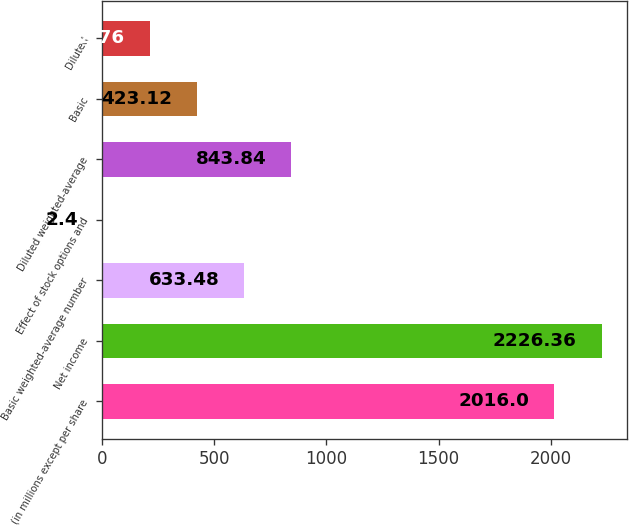<chart> <loc_0><loc_0><loc_500><loc_500><bar_chart><fcel>(in millions except per share<fcel>Net income<fcel>Basic weighted-average number<fcel>Effect of stock options and<fcel>Diluted weighted-average<fcel>Basic<fcel>Diluted<nl><fcel>2016<fcel>2226.36<fcel>633.48<fcel>2.4<fcel>843.84<fcel>423.12<fcel>212.76<nl></chart> 